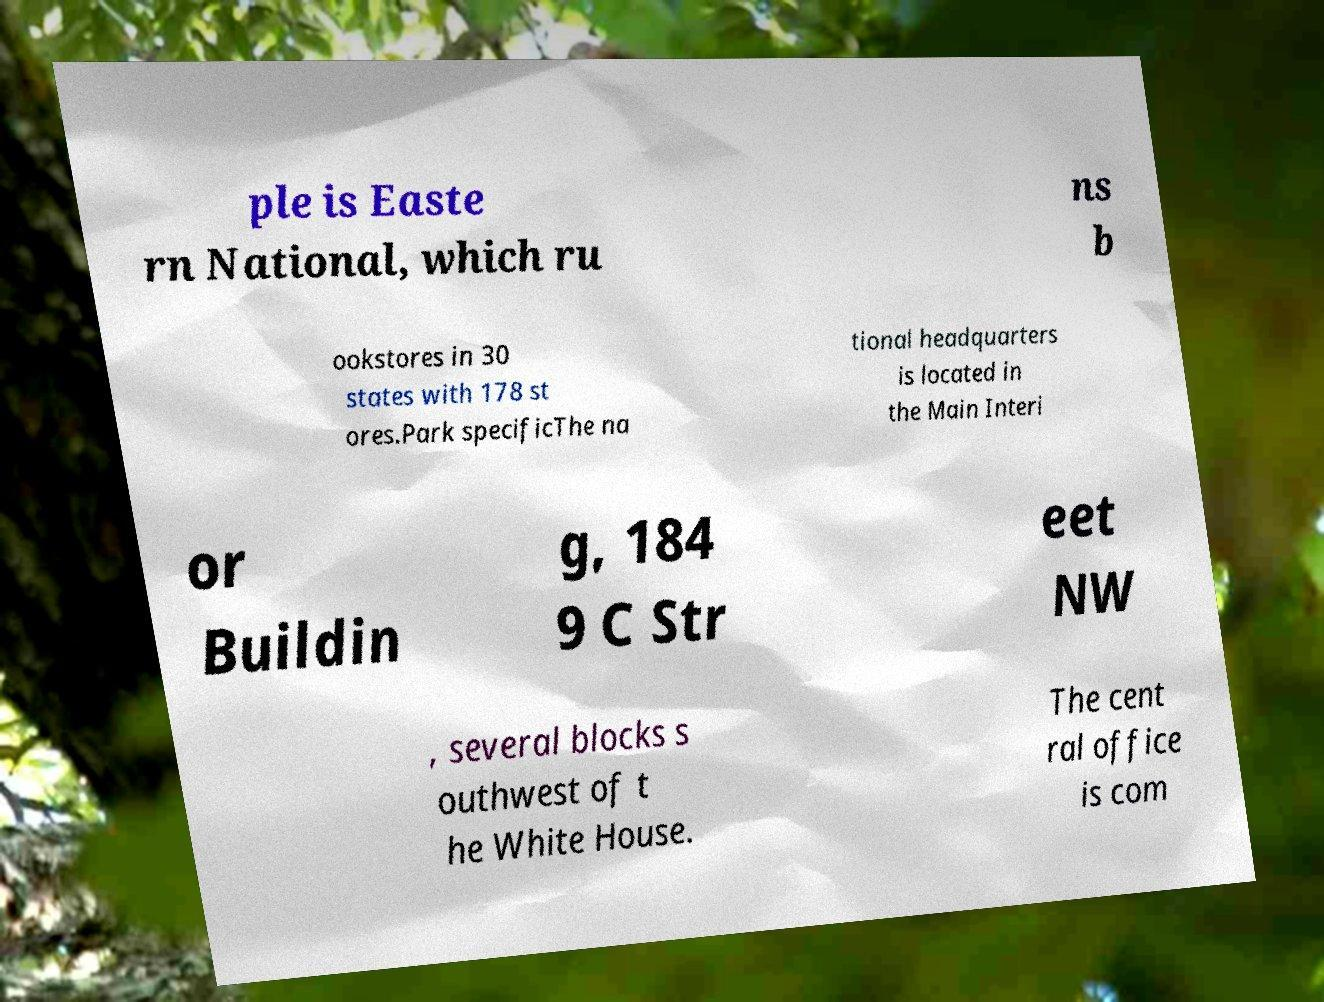What messages or text are displayed in this image? I need them in a readable, typed format. ple is Easte rn National, which ru ns b ookstores in 30 states with 178 st ores.Park specificThe na tional headquarters is located in the Main Interi or Buildin g, 184 9 C Str eet NW , several blocks s outhwest of t he White House. The cent ral office is com 